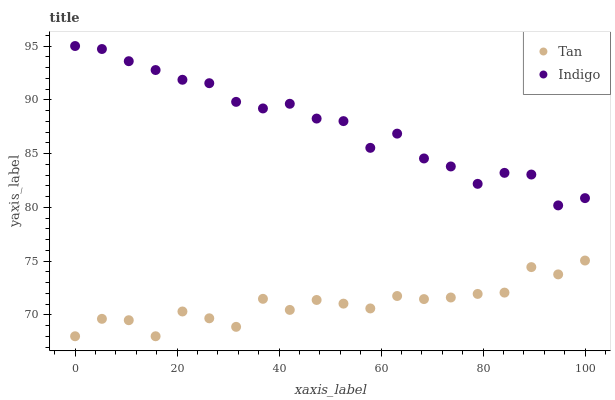Does Tan have the minimum area under the curve?
Answer yes or no. Yes. Does Indigo have the maximum area under the curve?
Answer yes or no. Yes. Does Indigo have the minimum area under the curve?
Answer yes or no. No. Is Indigo the smoothest?
Answer yes or no. Yes. Is Tan the roughest?
Answer yes or no. Yes. Is Indigo the roughest?
Answer yes or no. No. Does Tan have the lowest value?
Answer yes or no. Yes. Does Indigo have the lowest value?
Answer yes or no. No. Does Indigo have the highest value?
Answer yes or no. Yes. Is Tan less than Indigo?
Answer yes or no. Yes. Is Indigo greater than Tan?
Answer yes or no. Yes. Does Tan intersect Indigo?
Answer yes or no. No. 